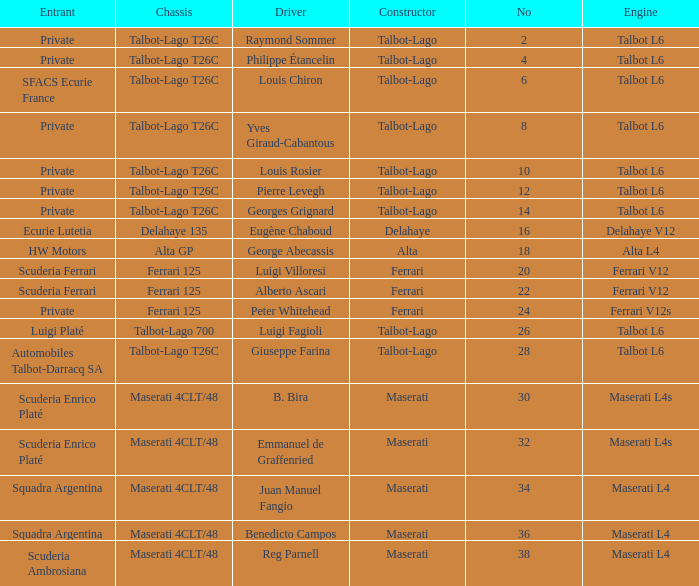Name the chassis for b. bira Maserati 4CLT/48. 